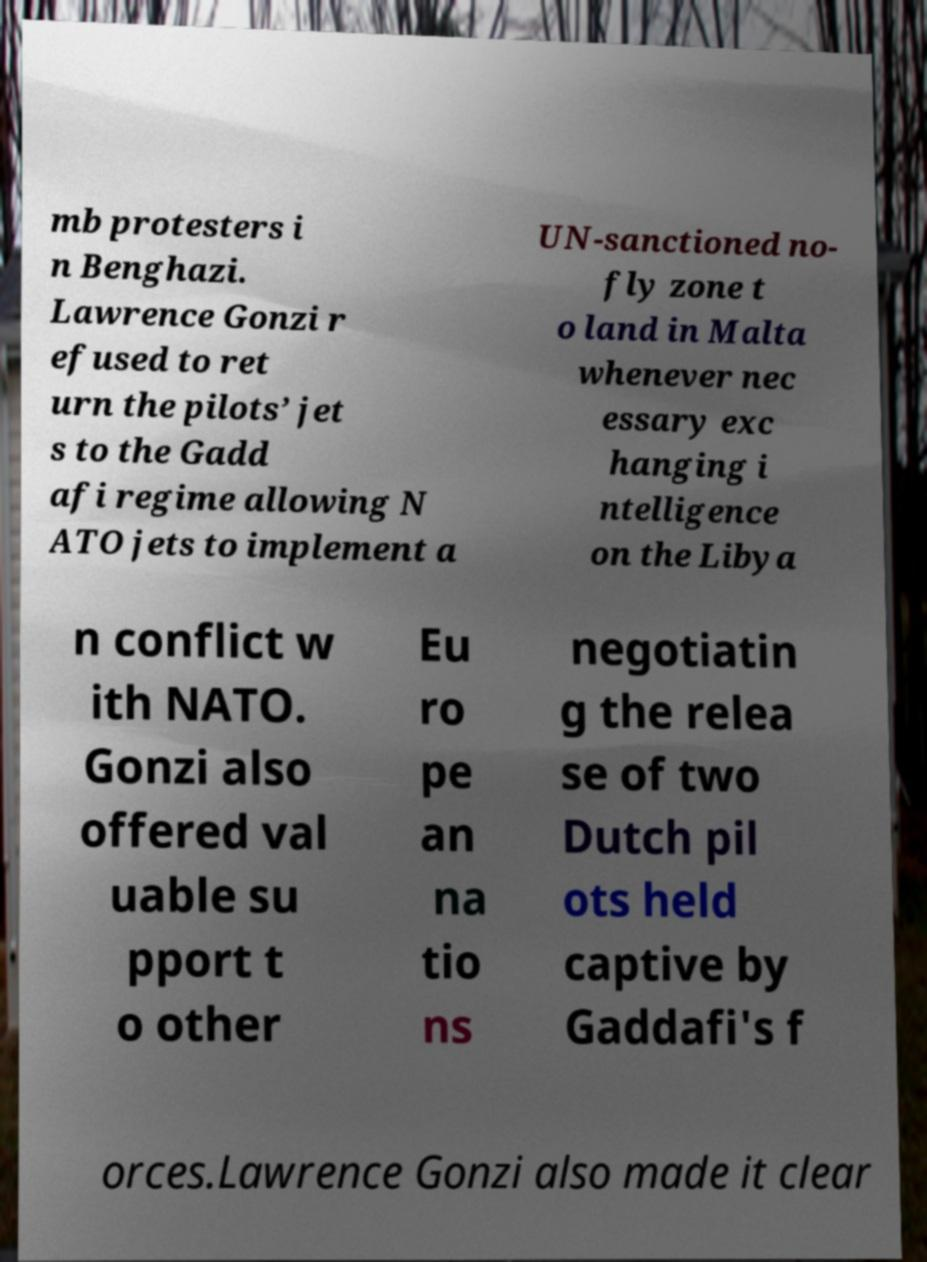For documentation purposes, I need the text within this image transcribed. Could you provide that? mb protesters i n Benghazi. Lawrence Gonzi r efused to ret urn the pilots’ jet s to the Gadd afi regime allowing N ATO jets to implement a UN-sanctioned no- fly zone t o land in Malta whenever nec essary exc hanging i ntelligence on the Libya n conflict w ith NATO. Gonzi also offered val uable su pport t o other Eu ro pe an na tio ns negotiatin g the relea se of two Dutch pil ots held captive by Gaddafi's f orces.Lawrence Gonzi also made it clear 